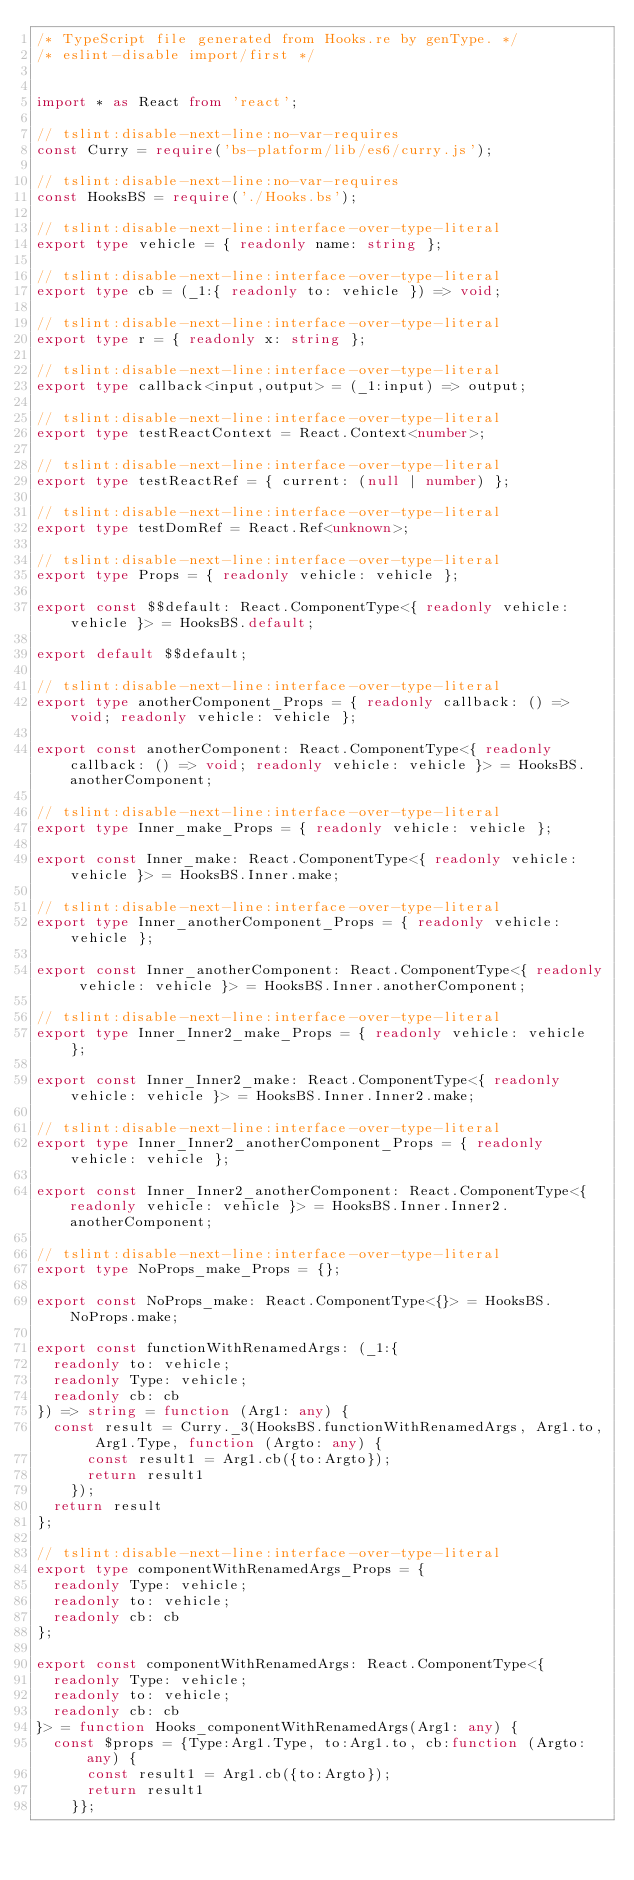Convert code to text. <code><loc_0><loc_0><loc_500><loc_500><_TypeScript_>/* TypeScript file generated from Hooks.re by genType. */
/* eslint-disable import/first */


import * as React from 'react';

// tslint:disable-next-line:no-var-requires
const Curry = require('bs-platform/lib/es6/curry.js');

// tslint:disable-next-line:no-var-requires
const HooksBS = require('./Hooks.bs');

// tslint:disable-next-line:interface-over-type-literal
export type vehicle = { readonly name: string };

// tslint:disable-next-line:interface-over-type-literal
export type cb = (_1:{ readonly to: vehicle }) => void;

// tslint:disable-next-line:interface-over-type-literal
export type r = { readonly x: string };

// tslint:disable-next-line:interface-over-type-literal
export type callback<input,output> = (_1:input) => output;

// tslint:disable-next-line:interface-over-type-literal
export type testReactContext = React.Context<number>;

// tslint:disable-next-line:interface-over-type-literal
export type testReactRef = { current: (null | number) };

// tslint:disable-next-line:interface-over-type-literal
export type testDomRef = React.Ref<unknown>;

// tslint:disable-next-line:interface-over-type-literal
export type Props = { readonly vehicle: vehicle };

export const $$default: React.ComponentType<{ readonly vehicle: vehicle }> = HooksBS.default;

export default $$default;

// tslint:disable-next-line:interface-over-type-literal
export type anotherComponent_Props = { readonly callback: () => void; readonly vehicle: vehicle };

export const anotherComponent: React.ComponentType<{ readonly callback: () => void; readonly vehicle: vehicle }> = HooksBS.anotherComponent;

// tslint:disable-next-line:interface-over-type-literal
export type Inner_make_Props = { readonly vehicle: vehicle };

export const Inner_make: React.ComponentType<{ readonly vehicle: vehicle }> = HooksBS.Inner.make;

// tslint:disable-next-line:interface-over-type-literal
export type Inner_anotherComponent_Props = { readonly vehicle: vehicle };

export const Inner_anotherComponent: React.ComponentType<{ readonly vehicle: vehicle }> = HooksBS.Inner.anotherComponent;

// tslint:disable-next-line:interface-over-type-literal
export type Inner_Inner2_make_Props = { readonly vehicle: vehicle };

export const Inner_Inner2_make: React.ComponentType<{ readonly vehicle: vehicle }> = HooksBS.Inner.Inner2.make;

// tslint:disable-next-line:interface-over-type-literal
export type Inner_Inner2_anotherComponent_Props = { readonly vehicle: vehicle };

export const Inner_Inner2_anotherComponent: React.ComponentType<{ readonly vehicle: vehicle }> = HooksBS.Inner.Inner2.anotherComponent;

// tslint:disable-next-line:interface-over-type-literal
export type NoProps_make_Props = {};

export const NoProps_make: React.ComponentType<{}> = HooksBS.NoProps.make;

export const functionWithRenamedArgs: (_1:{
  readonly to: vehicle; 
  readonly Type: vehicle; 
  readonly cb: cb
}) => string = function (Arg1: any) {
  const result = Curry._3(HooksBS.functionWithRenamedArgs, Arg1.to, Arg1.Type, function (Argto: any) {
      const result1 = Arg1.cb({to:Argto});
      return result1
    });
  return result
};

// tslint:disable-next-line:interface-over-type-literal
export type componentWithRenamedArgs_Props = {
  readonly Type: vehicle; 
  readonly to: vehicle; 
  readonly cb: cb
};

export const componentWithRenamedArgs: React.ComponentType<{
  readonly Type: vehicle; 
  readonly to: vehicle; 
  readonly cb: cb
}> = function Hooks_componentWithRenamedArgs(Arg1: any) {
  const $props = {Type:Arg1.Type, to:Arg1.to, cb:function (Argto: any) {
      const result1 = Arg1.cb({to:Argto});
      return result1
    }};</code> 